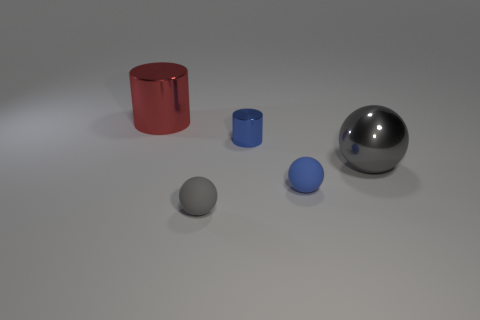Add 3 gray matte balls. How many objects exist? 8 Subtract all small blue spheres. How many spheres are left? 2 Subtract all blue cylinders. How many cylinders are left? 1 Subtract 1 blue balls. How many objects are left? 4 Subtract all balls. How many objects are left? 2 Subtract 2 spheres. How many spheres are left? 1 Subtract all yellow spheres. Subtract all purple cubes. How many spheres are left? 3 Subtract all cyan balls. How many purple cylinders are left? 0 Subtract all small blue rubber spheres. Subtract all blue rubber spheres. How many objects are left? 3 Add 3 big red metal cylinders. How many big red metal cylinders are left? 4 